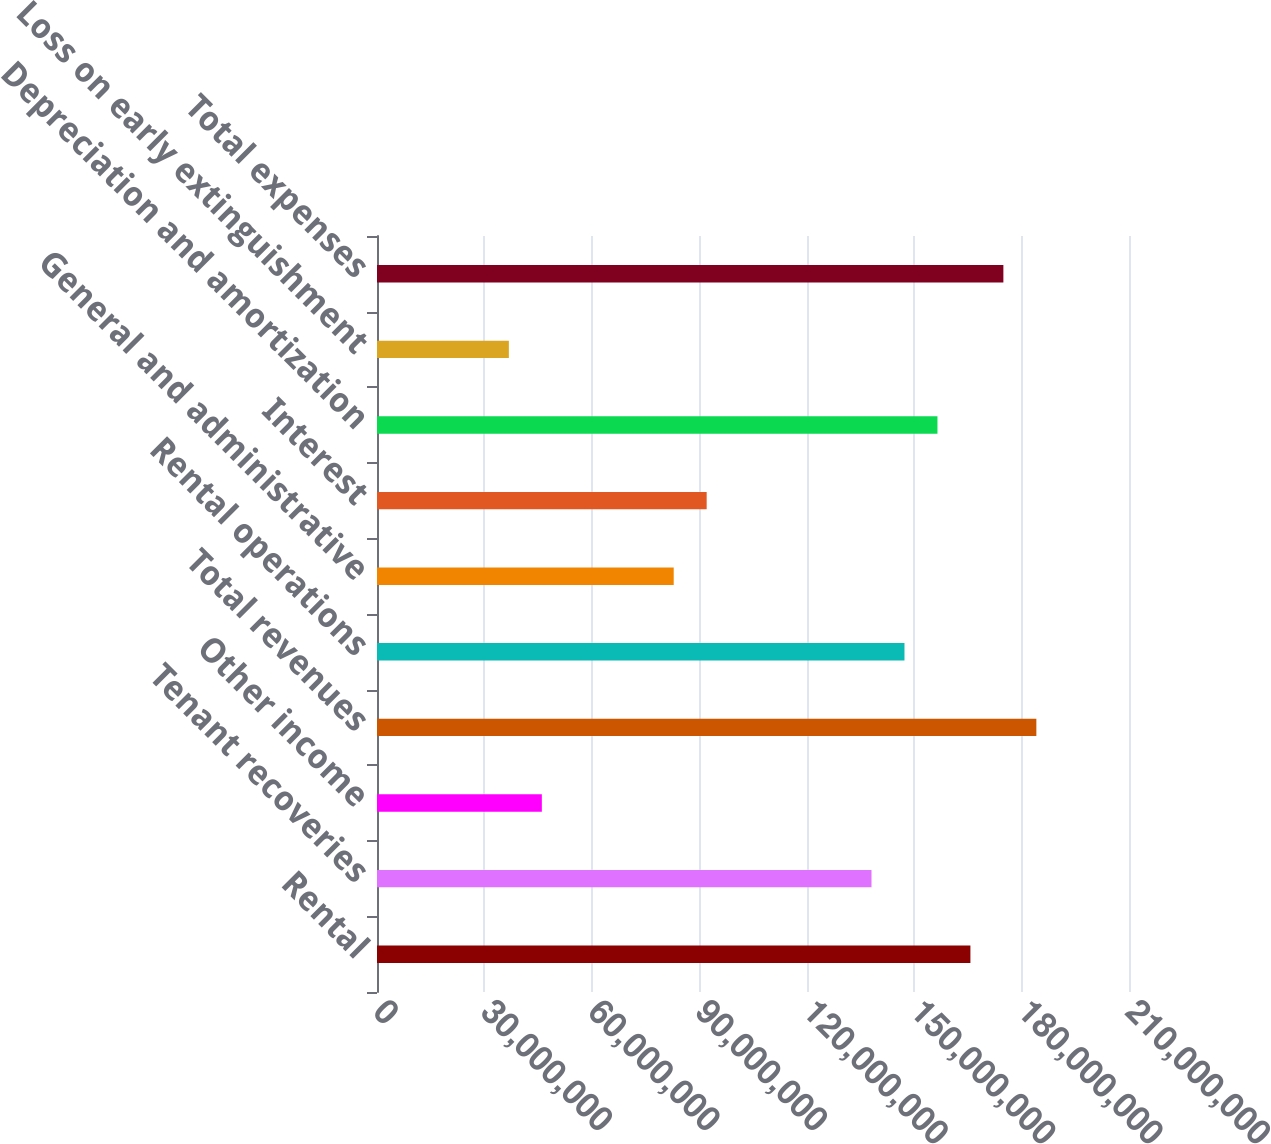Convert chart to OTSL. <chart><loc_0><loc_0><loc_500><loc_500><bar_chart><fcel>Rental<fcel>Tenant recoveries<fcel>Other income<fcel>Total revenues<fcel>Rental operations<fcel>General and administrative<fcel>Interest<fcel>Depreciation and amortization<fcel>Loss on early extinguishment<fcel>Total expenses<nl><fcel>1.65714e+08<fcel>1.38095e+08<fcel>4.60316e+07<fcel>1.84127e+08<fcel>1.47301e+08<fcel>8.28569e+07<fcel>9.20633e+07<fcel>1.56508e+08<fcel>3.68253e+07<fcel>1.7492e+08<nl></chart> 